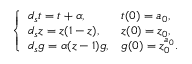<formula> <loc_0><loc_0><loc_500><loc_500>\left \{ \begin{array} { l l } { d _ { s } t = t + \alpha , } & { t ( 0 ) = a _ { 0 } , } \\ { d _ { s } z = z ( 1 - z ) , } & { z ( 0 ) = z _ { 0 } , } \\ { d _ { s } g = \alpha ( z - 1 ) g , } & { g ( 0 ) = z _ { 0 } ^ { a _ { 0 } } . } \end{array}</formula> 